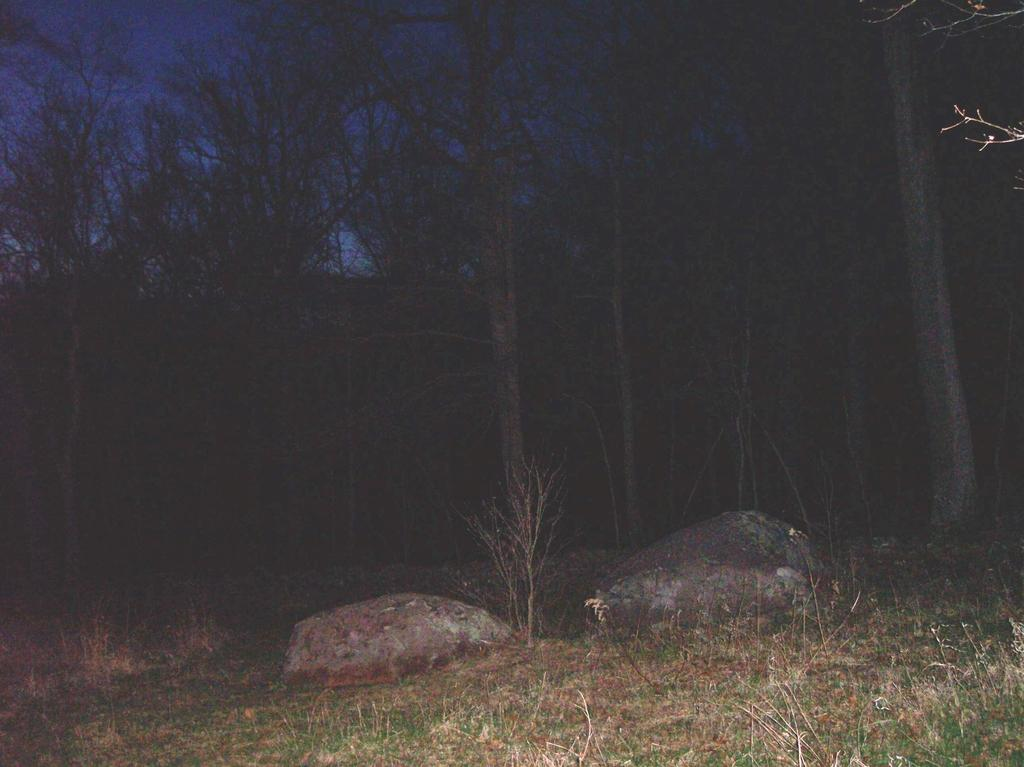What type of surface is visible in the image? There is a grass surface in the image. What objects can be seen on the grass surface? There are two rocks in the image. What type of vegetation is present in the image besides the grass? There are dried plants in the image. What can be seen in the background of the image? In the background of the image, there are trees visible. How would you describe the lighting in the image? The background of the image appears to be dark. What type of party is being held in the image? There is no party present in the image; it features a grass surface, rocks, dried plants, and trees in the background. What fact can be learned about the creature in the image? There is no creature present in the image, so no fact about a creature can be learned. 